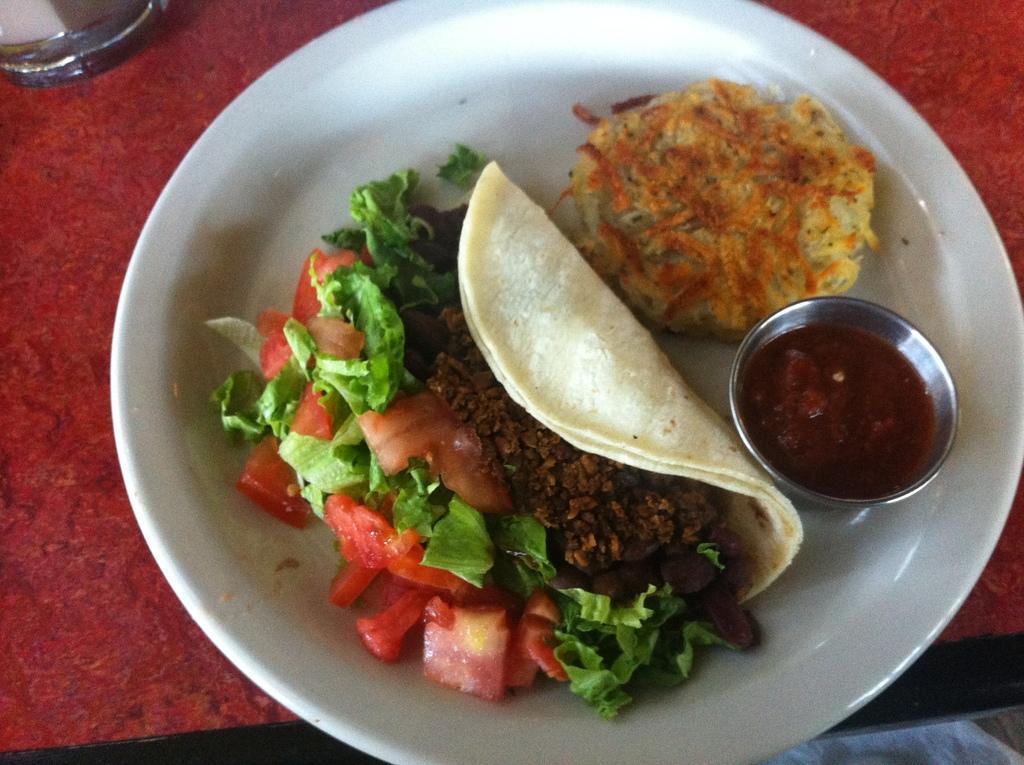In one or two sentences, can you explain what this image depicts? There is a plate and on the plate there are two food items and some sauce is served. 